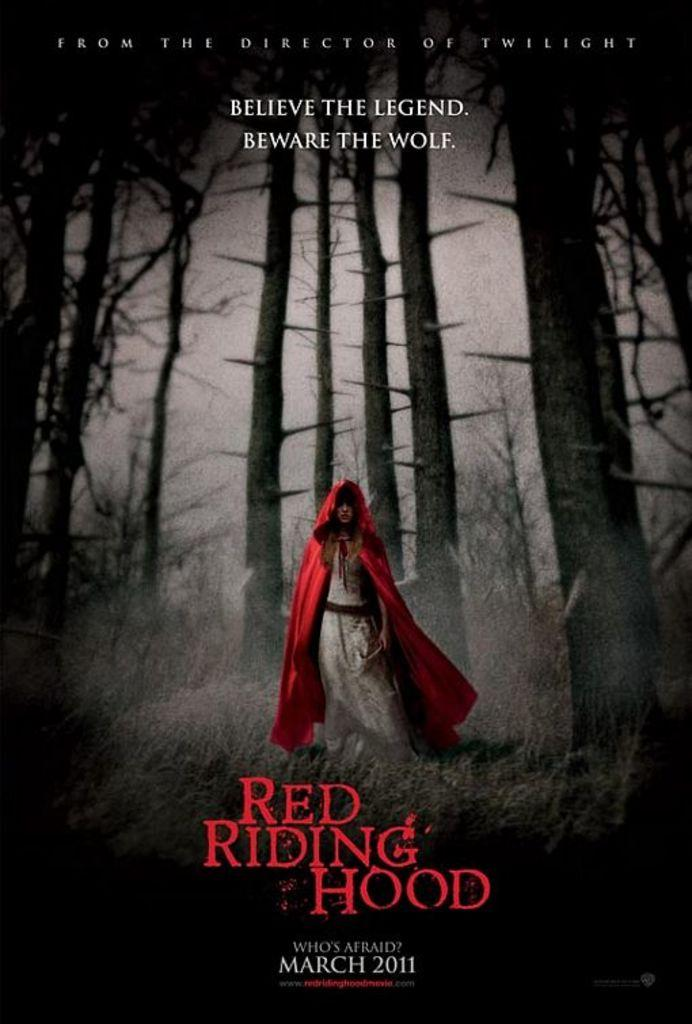Provide a one-sentence caption for the provided image. An ad for Red Riding Hood, released in 2011, features dark woods. 